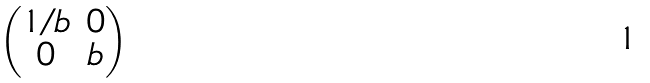<formula> <loc_0><loc_0><loc_500><loc_500>\begin{pmatrix} 1 / b & 0 \\ 0 & b \end{pmatrix}</formula> 